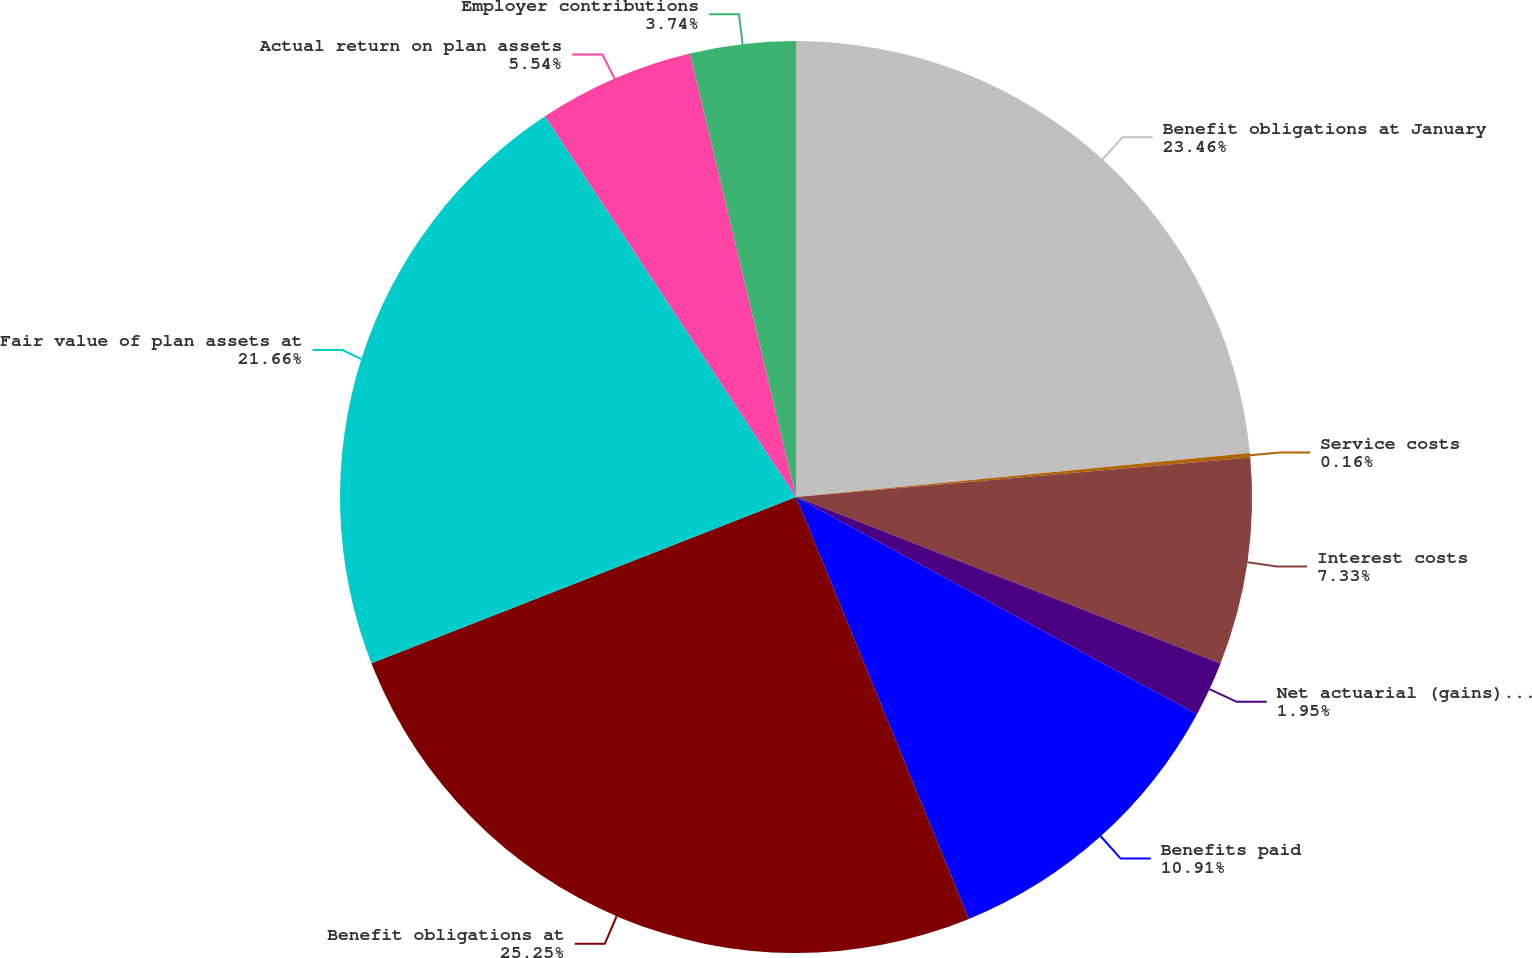Convert chart to OTSL. <chart><loc_0><loc_0><loc_500><loc_500><pie_chart><fcel>Benefit obligations at January<fcel>Service costs<fcel>Interest costs<fcel>Net actuarial (gains) losses<fcel>Benefits paid<fcel>Benefit obligations at<fcel>Fair value of plan assets at<fcel>Actual return on plan assets<fcel>Employer contributions<nl><fcel>23.46%<fcel>0.16%<fcel>7.33%<fcel>1.95%<fcel>10.91%<fcel>25.25%<fcel>21.66%<fcel>5.54%<fcel>3.74%<nl></chart> 